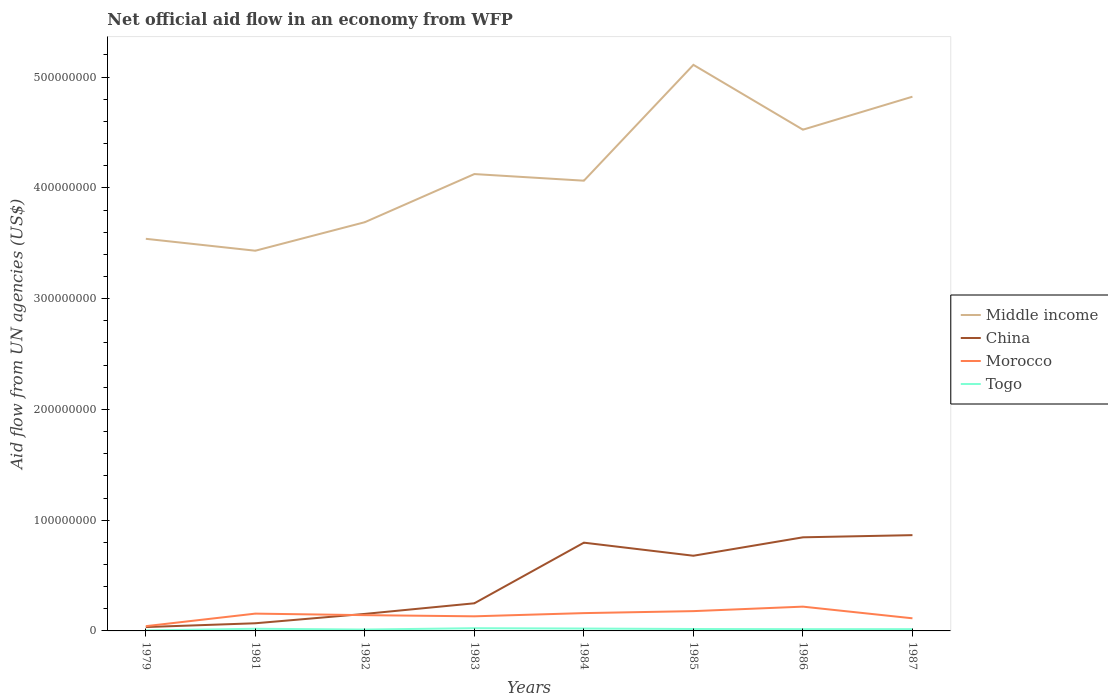How many different coloured lines are there?
Provide a succinct answer. 4. Does the line corresponding to Morocco intersect with the line corresponding to China?
Provide a short and direct response. Yes. What is the total net official aid flow in Morocco in the graph?
Your answer should be very brief. -9.95e+06. What is the difference between the highest and the second highest net official aid flow in China?
Your answer should be very brief. 8.30e+07. What is the difference between the highest and the lowest net official aid flow in Togo?
Ensure brevity in your answer.  4. Is the net official aid flow in Togo strictly greater than the net official aid flow in Middle income over the years?
Offer a very short reply. Yes. How many lines are there?
Offer a terse response. 4. How many years are there in the graph?
Keep it short and to the point. 8. Does the graph contain any zero values?
Your answer should be compact. No. Does the graph contain grids?
Ensure brevity in your answer.  No. How many legend labels are there?
Your response must be concise. 4. What is the title of the graph?
Your answer should be compact. Net official aid flow in an economy from WFP. What is the label or title of the Y-axis?
Ensure brevity in your answer.  Aid flow from UN agencies (US$). What is the Aid flow from UN agencies (US$) in Middle income in 1979?
Provide a short and direct response. 3.54e+08. What is the Aid flow from UN agencies (US$) of China in 1979?
Offer a very short reply. 3.48e+06. What is the Aid flow from UN agencies (US$) in Morocco in 1979?
Your answer should be very brief. 4.29e+06. What is the Aid flow from UN agencies (US$) in Middle income in 1981?
Keep it short and to the point. 3.43e+08. What is the Aid flow from UN agencies (US$) of China in 1981?
Provide a short and direct response. 6.91e+06. What is the Aid flow from UN agencies (US$) of Morocco in 1981?
Keep it short and to the point. 1.56e+07. What is the Aid flow from UN agencies (US$) in Togo in 1981?
Provide a succinct answer. 1.96e+06. What is the Aid flow from UN agencies (US$) in Middle income in 1982?
Provide a succinct answer. 3.69e+08. What is the Aid flow from UN agencies (US$) of China in 1982?
Make the answer very short. 1.54e+07. What is the Aid flow from UN agencies (US$) in Morocco in 1982?
Provide a succinct answer. 1.42e+07. What is the Aid flow from UN agencies (US$) of Togo in 1982?
Offer a terse response. 1.24e+06. What is the Aid flow from UN agencies (US$) of Middle income in 1983?
Your response must be concise. 4.12e+08. What is the Aid flow from UN agencies (US$) of China in 1983?
Keep it short and to the point. 2.50e+07. What is the Aid flow from UN agencies (US$) in Morocco in 1983?
Provide a short and direct response. 1.32e+07. What is the Aid flow from UN agencies (US$) of Togo in 1983?
Provide a succinct answer. 2.45e+06. What is the Aid flow from UN agencies (US$) in Middle income in 1984?
Provide a succinct answer. 4.06e+08. What is the Aid flow from UN agencies (US$) in China in 1984?
Offer a terse response. 7.97e+07. What is the Aid flow from UN agencies (US$) in Morocco in 1984?
Give a very brief answer. 1.61e+07. What is the Aid flow from UN agencies (US$) in Togo in 1984?
Your response must be concise. 2.15e+06. What is the Aid flow from UN agencies (US$) in Middle income in 1985?
Ensure brevity in your answer.  5.11e+08. What is the Aid flow from UN agencies (US$) of China in 1985?
Give a very brief answer. 6.79e+07. What is the Aid flow from UN agencies (US$) in Morocco in 1985?
Your answer should be very brief. 1.79e+07. What is the Aid flow from UN agencies (US$) of Togo in 1985?
Your response must be concise. 1.74e+06. What is the Aid flow from UN agencies (US$) of Middle income in 1986?
Keep it short and to the point. 4.53e+08. What is the Aid flow from UN agencies (US$) in China in 1986?
Keep it short and to the point. 8.45e+07. What is the Aid flow from UN agencies (US$) in Morocco in 1986?
Provide a succinct answer. 2.19e+07. What is the Aid flow from UN agencies (US$) of Togo in 1986?
Give a very brief answer. 1.58e+06. What is the Aid flow from UN agencies (US$) of Middle income in 1987?
Provide a succinct answer. 4.82e+08. What is the Aid flow from UN agencies (US$) of China in 1987?
Offer a terse response. 8.65e+07. What is the Aid flow from UN agencies (US$) of Morocco in 1987?
Provide a succinct answer. 1.14e+07. What is the Aid flow from UN agencies (US$) of Togo in 1987?
Your answer should be very brief. 1.59e+06. Across all years, what is the maximum Aid flow from UN agencies (US$) in Middle income?
Offer a very short reply. 5.11e+08. Across all years, what is the maximum Aid flow from UN agencies (US$) in China?
Provide a succinct answer. 8.65e+07. Across all years, what is the maximum Aid flow from UN agencies (US$) in Morocco?
Your answer should be very brief. 2.19e+07. Across all years, what is the maximum Aid flow from UN agencies (US$) in Togo?
Offer a very short reply. 2.45e+06. Across all years, what is the minimum Aid flow from UN agencies (US$) in Middle income?
Your answer should be compact. 3.43e+08. Across all years, what is the minimum Aid flow from UN agencies (US$) of China?
Keep it short and to the point. 3.48e+06. Across all years, what is the minimum Aid flow from UN agencies (US$) of Morocco?
Keep it short and to the point. 4.29e+06. What is the total Aid flow from UN agencies (US$) of Middle income in the graph?
Offer a terse response. 3.33e+09. What is the total Aid flow from UN agencies (US$) of China in the graph?
Your answer should be compact. 3.69e+08. What is the total Aid flow from UN agencies (US$) in Morocco in the graph?
Your answer should be very brief. 1.15e+08. What is the total Aid flow from UN agencies (US$) in Togo in the graph?
Your answer should be very brief. 1.32e+07. What is the difference between the Aid flow from UN agencies (US$) in Middle income in 1979 and that in 1981?
Offer a terse response. 1.08e+07. What is the difference between the Aid flow from UN agencies (US$) of China in 1979 and that in 1981?
Offer a terse response. -3.43e+06. What is the difference between the Aid flow from UN agencies (US$) in Morocco in 1979 and that in 1981?
Make the answer very short. -1.13e+07. What is the difference between the Aid flow from UN agencies (US$) in Togo in 1979 and that in 1981?
Keep it short and to the point. -1.49e+06. What is the difference between the Aid flow from UN agencies (US$) of Middle income in 1979 and that in 1982?
Ensure brevity in your answer.  -1.50e+07. What is the difference between the Aid flow from UN agencies (US$) in China in 1979 and that in 1982?
Make the answer very short. -1.19e+07. What is the difference between the Aid flow from UN agencies (US$) in Morocco in 1979 and that in 1982?
Give a very brief answer. -9.95e+06. What is the difference between the Aid flow from UN agencies (US$) in Togo in 1979 and that in 1982?
Make the answer very short. -7.70e+05. What is the difference between the Aid flow from UN agencies (US$) of Middle income in 1979 and that in 1983?
Offer a terse response. -5.84e+07. What is the difference between the Aid flow from UN agencies (US$) of China in 1979 and that in 1983?
Ensure brevity in your answer.  -2.15e+07. What is the difference between the Aid flow from UN agencies (US$) in Morocco in 1979 and that in 1983?
Offer a terse response. -8.90e+06. What is the difference between the Aid flow from UN agencies (US$) of Togo in 1979 and that in 1983?
Ensure brevity in your answer.  -1.98e+06. What is the difference between the Aid flow from UN agencies (US$) of Middle income in 1979 and that in 1984?
Your response must be concise. -5.25e+07. What is the difference between the Aid flow from UN agencies (US$) of China in 1979 and that in 1984?
Offer a terse response. -7.62e+07. What is the difference between the Aid flow from UN agencies (US$) in Morocco in 1979 and that in 1984?
Give a very brief answer. -1.18e+07. What is the difference between the Aid flow from UN agencies (US$) in Togo in 1979 and that in 1984?
Your answer should be compact. -1.68e+06. What is the difference between the Aid flow from UN agencies (US$) of Middle income in 1979 and that in 1985?
Keep it short and to the point. -1.57e+08. What is the difference between the Aid flow from UN agencies (US$) in China in 1979 and that in 1985?
Give a very brief answer. -6.44e+07. What is the difference between the Aid flow from UN agencies (US$) of Morocco in 1979 and that in 1985?
Keep it short and to the point. -1.36e+07. What is the difference between the Aid flow from UN agencies (US$) of Togo in 1979 and that in 1985?
Your answer should be compact. -1.27e+06. What is the difference between the Aid flow from UN agencies (US$) in Middle income in 1979 and that in 1986?
Provide a short and direct response. -9.85e+07. What is the difference between the Aid flow from UN agencies (US$) of China in 1979 and that in 1986?
Your answer should be compact. -8.10e+07. What is the difference between the Aid flow from UN agencies (US$) of Morocco in 1979 and that in 1986?
Offer a very short reply. -1.76e+07. What is the difference between the Aid flow from UN agencies (US$) in Togo in 1979 and that in 1986?
Your response must be concise. -1.11e+06. What is the difference between the Aid flow from UN agencies (US$) in Middle income in 1979 and that in 1987?
Offer a very short reply. -1.28e+08. What is the difference between the Aid flow from UN agencies (US$) of China in 1979 and that in 1987?
Offer a very short reply. -8.30e+07. What is the difference between the Aid flow from UN agencies (US$) in Morocco in 1979 and that in 1987?
Your answer should be compact. -7.10e+06. What is the difference between the Aid flow from UN agencies (US$) of Togo in 1979 and that in 1987?
Your response must be concise. -1.12e+06. What is the difference between the Aid flow from UN agencies (US$) in Middle income in 1981 and that in 1982?
Provide a short and direct response. -2.58e+07. What is the difference between the Aid flow from UN agencies (US$) in China in 1981 and that in 1982?
Your response must be concise. -8.46e+06. What is the difference between the Aid flow from UN agencies (US$) in Morocco in 1981 and that in 1982?
Give a very brief answer. 1.38e+06. What is the difference between the Aid flow from UN agencies (US$) in Togo in 1981 and that in 1982?
Your answer should be compact. 7.20e+05. What is the difference between the Aid flow from UN agencies (US$) of Middle income in 1981 and that in 1983?
Your answer should be very brief. -6.92e+07. What is the difference between the Aid flow from UN agencies (US$) of China in 1981 and that in 1983?
Your response must be concise. -1.80e+07. What is the difference between the Aid flow from UN agencies (US$) in Morocco in 1981 and that in 1983?
Make the answer very short. 2.43e+06. What is the difference between the Aid flow from UN agencies (US$) of Togo in 1981 and that in 1983?
Provide a succinct answer. -4.90e+05. What is the difference between the Aid flow from UN agencies (US$) of Middle income in 1981 and that in 1984?
Give a very brief answer. -6.32e+07. What is the difference between the Aid flow from UN agencies (US$) of China in 1981 and that in 1984?
Make the answer very short. -7.28e+07. What is the difference between the Aid flow from UN agencies (US$) in Morocco in 1981 and that in 1984?
Keep it short and to the point. -4.60e+05. What is the difference between the Aid flow from UN agencies (US$) in Middle income in 1981 and that in 1985?
Your answer should be very brief. -1.68e+08. What is the difference between the Aid flow from UN agencies (US$) of China in 1981 and that in 1985?
Keep it short and to the point. -6.10e+07. What is the difference between the Aid flow from UN agencies (US$) in Morocco in 1981 and that in 1985?
Your answer should be compact. -2.25e+06. What is the difference between the Aid flow from UN agencies (US$) of Togo in 1981 and that in 1985?
Your response must be concise. 2.20e+05. What is the difference between the Aid flow from UN agencies (US$) of Middle income in 1981 and that in 1986?
Your response must be concise. -1.09e+08. What is the difference between the Aid flow from UN agencies (US$) of China in 1981 and that in 1986?
Make the answer very short. -7.76e+07. What is the difference between the Aid flow from UN agencies (US$) in Morocco in 1981 and that in 1986?
Provide a succinct answer. -6.30e+06. What is the difference between the Aid flow from UN agencies (US$) of Middle income in 1981 and that in 1987?
Your answer should be compact. -1.39e+08. What is the difference between the Aid flow from UN agencies (US$) in China in 1981 and that in 1987?
Ensure brevity in your answer.  -7.96e+07. What is the difference between the Aid flow from UN agencies (US$) of Morocco in 1981 and that in 1987?
Ensure brevity in your answer.  4.23e+06. What is the difference between the Aid flow from UN agencies (US$) in Middle income in 1982 and that in 1983?
Provide a short and direct response. -4.34e+07. What is the difference between the Aid flow from UN agencies (US$) in China in 1982 and that in 1983?
Ensure brevity in your answer.  -9.58e+06. What is the difference between the Aid flow from UN agencies (US$) of Morocco in 1982 and that in 1983?
Make the answer very short. 1.05e+06. What is the difference between the Aid flow from UN agencies (US$) of Togo in 1982 and that in 1983?
Your answer should be very brief. -1.21e+06. What is the difference between the Aid flow from UN agencies (US$) of Middle income in 1982 and that in 1984?
Provide a short and direct response. -3.75e+07. What is the difference between the Aid flow from UN agencies (US$) of China in 1982 and that in 1984?
Your response must be concise. -6.43e+07. What is the difference between the Aid flow from UN agencies (US$) in Morocco in 1982 and that in 1984?
Give a very brief answer. -1.84e+06. What is the difference between the Aid flow from UN agencies (US$) of Togo in 1982 and that in 1984?
Give a very brief answer. -9.10e+05. What is the difference between the Aid flow from UN agencies (US$) in Middle income in 1982 and that in 1985?
Make the answer very short. -1.42e+08. What is the difference between the Aid flow from UN agencies (US$) in China in 1982 and that in 1985?
Your answer should be very brief. -5.25e+07. What is the difference between the Aid flow from UN agencies (US$) of Morocco in 1982 and that in 1985?
Give a very brief answer. -3.63e+06. What is the difference between the Aid flow from UN agencies (US$) of Togo in 1982 and that in 1985?
Provide a short and direct response. -5.00e+05. What is the difference between the Aid flow from UN agencies (US$) of Middle income in 1982 and that in 1986?
Make the answer very short. -8.35e+07. What is the difference between the Aid flow from UN agencies (US$) in China in 1982 and that in 1986?
Provide a succinct answer. -6.91e+07. What is the difference between the Aid flow from UN agencies (US$) in Morocco in 1982 and that in 1986?
Make the answer very short. -7.68e+06. What is the difference between the Aid flow from UN agencies (US$) in Middle income in 1982 and that in 1987?
Offer a terse response. -1.13e+08. What is the difference between the Aid flow from UN agencies (US$) in China in 1982 and that in 1987?
Make the answer very short. -7.11e+07. What is the difference between the Aid flow from UN agencies (US$) of Morocco in 1982 and that in 1987?
Your answer should be compact. 2.85e+06. What is the difference between the Aid flow from UN agencies (US$) in Togo in 1982 and that in 1987?
Ensure brevity in your answer.  -3.50e+05. What is the difference between the Aid flow from UN agencies (US$) in Middle income in 1983 and that in 1984?
Provide a succinct answer. 5.98e+06. What is the difference between the Aid flow from UN agencies (US$) of China in 1983 and that in 1984?
Provide a succinct answer. -5.47e+07. What is the difference between the Aid flow from UN agencies (US$) in Morocco in 1983 and that in 1984?
Provide a succinct answer. -2.89e+06. What is the difference between the Aid flow from UN agencies (US$) in Middle income in 1983 and that in 1985?
Offer a very short reply. -9.86e+07. What is the difference between the Aid flow from UN agencies (US$) of China in 1983 and that in 1985?
Keep it short and to the point. -4.29e+07. What is the difference between the Aid flow from UN agencies (US$) of Morocco in 1983 and that in 1985?
Ensure brevity in your answer.  -4.68e+06. What is the difference between the Aid flow from UN agencies (US$) of Togo in 1983 and that in 1985?
Offer a very short reply. 7.10e+05. What is the difference between the Aid flow from UN agencies (US$) in Middle income in 1983 and that in 1986?
Your response must be concise. -4.01e+07. What is the difference between the Aid flow from UN agencies (US$) of China in 1983 and that in 1986?
Ensure brevity in your answer.  -5.96e+07. What is the difference between the Aid flow from UN agencies (US$) of Morocco in 1983 and that in 1986?
Make the answer very short. -8.73e+06. What is the difference between the Aid flow from UN agencies (US$) in Togo in 1983 and that in 1986?
Keep it short and to the point. 8.70e+05. What is the difference between the Aid flow from UN agencies (US$) of Middle income in 1983 and that in 1987?
Offer a terse response. -6.99e+07. What is the difference between the Aid flow from UN agencies (US$) of China in 1983 and that in 1987?
Your response must be concise. -6.15e+07. What is the difference between the Aid flow from UN agencies (US$) in Morocco in 1983 and that in 1987?
Your response must be concise. 1.80e+06. What is the difference between the Aid flow from UN agencies (US$) in Togo in 1983 and that in 1987?
Offer a very short reply. 8.60e+05. What is the difference between the Aid flow from UN agencies (US$) in Middle income in 1984 and that in 1985?
Your answer should be compact. -1.05e+08. What is the difference between the Aid flow from UN agencies (US$) in China in 1984 and that in 1985?
Give a very brief answer. 1.18e+07. What is the difference between the Aid flow from UN agencies (US$) of Morocco in 1984 and that in 1985?
Your response must be concise. -1.79e+06. What is the difference between the Aid flow from UN agencies (US$) in Togo in 1984 and that in 1985?
Make the answer very short. 4.10e+05. What is the difference between the Aid flow from UN agencies (US$) in Middle income in 1984 and that in 1986?
Keep it short and to the point. -4.60e+07. What is the difference between the Aid flow from UN agencies (US$) of China in 1984 and that in 1986?
Make the answer very short. -4.83e+06. What is the difference between the Aid flow from UN agencies (US$) in Morocco in 1984 and that in 1986?
Offer a terse response. -5.84e+06. What is the difference between the Aid flow from UN agencies (US$) of Togo in 1984 and that in 1986?
Provide a short and direct response. 5.70e+05. What is the difference between the Aid flow from UN agencies (US$) in Middle income in 1984 and that in 1987?
Keep it short and to the point. -7.58e+07. What is the difference between the Aid flow from UN agencies (US$) of China in 1984 and that in 1987?
Your response must be concise. -6.79e+06. What is the difference between the Aid flow from UN agencies (US$) in Morocco in 1984 and that in 1987?
Your answer should be very brief. 4.69e+06. What is the difference between the Aid flow from UN agencies (US$) in Togo in 1984 and that in 1987?
Your answer should be very brief. 5.60e+05. What is the difference between the Aid flow from UN agencies (US$) of Middle income in 1985 and that in 1986?
Ensure brevity in your answer.  5.85e+07. What is the difference between the Aid flow from UN agencies (US$) in China in 1985 and that in 1986?
Your answer should be compact. -1.66e+07. What is the difference between the Aid flow from UN agencies (US$) in Morocco in 1985 and that in 1986?
Your answer should be very brief. -4.05e+06. What is the difference between the Aid flow from UN agencies (US$) in Togo in 1985 and that in 1986?
Your answer should be compact. 1.60e+05. What is the difference between the Aid flow from UN agencies (US$) of Middle income in 1985 and that in 1987?
Keep it short and to the point. 2.87e+07. What is the difference between the Aid flow from UN agencies (US$) of China in 1985 and that in 1987?
Ensure brevity in your answer.  -1.86e+07. What is the difference between the Aid flow from UN agencies (US$) of Morocco in 1985 and that in 1987?
Ensure brevity in your answer.  6.48e+06. What is the difference between the Aid flow from UN agencies (US$) of Middle income in 1986 and that in 1987?
Provide a succinct answer. -2.98e+07. What is the difference between the Aid flow from UN agencies (US$) in China in 1986 and that in 1987?
Keep it short and to the point. -1.96e+06. What is the difference between the Aid flow from UN agencies (US$) of Morocco in 1986 and that in 1987?
Ensure brevity in your answer.  1.05e+07. What is the difference between the Aid flow from UN agencies (US$) in Togo in 1986 and that in 1987?
Keep it short and to the point. -10000. What is the difference between the Aid flow from UN agencies (US$) of Middle income in 1979 and the Aid flow from UN agencies (US$) of China in 1981?
Keep it short and to the point. 3.47e+08. What is the difference between the Aid flow from UN agencies (US$) of Middle income in 1979 and the Aid flow from UN agencies (US$) of Morocco in 1981?
Offer a terse response. 3.38e+08. What is the difference between the Aid flow from UN agencies (US$) in Middle income in 1979 and the Aid flow from UN agencies (US$) in Togo in 1981?
Give a very brief answer. 3.52e+08. What is the difference between the Aid flow from UN agencies (US$) in China in 1979 and the Aid flow from UN agencies (US$) in Morocco in 1981?
Your answer should be compact. -1.21e+07. What is the difference between the Aid flow from UN agencies (US$) in China in 1979 and the Aid flow from UN agencies (US$) in Togo in 1981?
Provide a short and direct response. 1.52e+06. What is the difference between the Aid flow from UN agencies (US$) in Morocco in 1979 and the Aid flow from UN agencies (US$) in Togo in 1981?
Keep it short and to the point. 2.33e+06. What is the difference between the Aid flow from UN agencies (US$) in Middle income in 1979 and the Aid flow from UN agencies (US$) in China in 1982?
Your response must be concise. 3.39e+08. What is the difference between the Aid flow from UN agencies (US$) in Middle income in 1979 and the Aid flow from UN agencies (US$) in Morocco in 1982?
Provide a succinct answer. 3.40e+08. What is the difference between the Aid flow from UN agencies (US$) of Middle income in 1979 and the Aid flow from UN agencies (US$) of Togo in 1982?
Your answer should be very brief. 3.53e+08. What is the difference between the Aid flow from UN agencies (US$) of China in 1979 and the Aid flow from UN agencies (US$) of Morocco in 1982?
Keep it short and to the point. -1.08e+07. What is the difference between the Aid flow from UN agencies (US$) of China in 1979 and the Aid flow from UN agencies (US$) of Togo in 1982?
Offer a very short reply. 2.24e+06. What is the difference between the Aid flow from UN agencies (US$) in Morocco in 1979 and the Aid flow from UN agencies (US$) in Togo in 1982?
Offer a very short reply. 3.05e+06. What is the difference between the Aid flow from UN agencies (US$) of Middle income in 1979 and the Aid flow from UN agencies (US$) of China in 1983?
Ensure brevity in your answer.  3.29e+08. What is the difference between the Aid flow from UN agencies (US$) in Middle income in 1979 and the Aid flow from UN agencies (US$) in Morocco in 1983?
Provide a succinct answer. 3.41e+08. What is the difference between the Aid flow from UN agencies (US$) in Middle income in 1979 and the Aid flow from UN agencies (US$) in Togo in 1983?
Offer a very short reply. 3.52e+08. What is the difference between the Aid flow from UN agencies (US$) in China in 1979 and the Aid flow from UN agencies (US$) in Morocco in 1983?
Keep it short and to the point. -9.71e+06. What is the difference between the Aid flow from UN agencies (US$) in China in 1979 and the Aid flow from UN agencies (US$) in Togo in 1983?
Your response must be concise. 1.03e+06. What is the difference between the Aid flow from UN agencies (US$) in Morocco in 1979 and the Aid flow from UN agencies (US$) in Togo in 1983?
Your answer should be very brief. 1.84e+06. What is the difference between the Aid flow from UN agencies (US$) in Middle income in 1979 and the Aid flow from UN agencies (US$) in China in 1984?
Your answer should be very brief. 2.74e+08. What is the difference between the Aid flow from UN agencies (US$) in Middle income in 1979 and the Aid flow from UN agencies (US$) in Morocco in 1984?
Give a very brief answer. 3.38e+08. What is the difference between the Aid flow from UN agencies (US$) of Middle income in 1979 and the Aid flow from UN agencies (US$) of Togo in 1984?
Give a very brief answer. 3.52e+08. What is the difference between the Aid flow from UN agencies (US$) in China in 1979 and the Aid flow from UN agencies (US$) in Morocco in 1984?
Keep it short and to the point. -1.26e+07. What is the difference between the Aid flow from UN agencies (US$) of China in 1979 and the Aid flow from UN agencies (US$) of Togo in 1984?
Your response must be concise. 1.33e+06. What is the difference between the Aid flow from UN agencies (US$) of Morocco in 1979 and the Aid flow from UN agencies (US$) of Togo in 1984?
Your answer should be very brief. 2.14e+06. What is the difference between the Aid flow from UN agencies (US$) in Middle income in 1979 and the Aid flow from UN agencies (US$) in China in 1985?
Ensure brevity in your answer.  2.86e+08. What is the difference between the Aid flow from UN agencies (US$) in Middle income in 1979 and the Aid flow from UN agencies (US$) in Morocco in 1985?
Provide a short and direct response. 3.36e+08. What is the difference between the Aid flow from UN agencies (US$) in Middle income in 1979 and the Aid flow from UN agencies (US$) in Togo in 1985?
Your answer should be very brief. 3.52e+08. What is the difference between the Aid flow from UN agencies (US$) in China in 1979 and the Aid flow from UN agencies (US$) in Morocco in 1985?
Make the answer very short. -1.44e+07. What is the difference between the Aid flow from UN agencies (US$) of China in 1979 and the Aid flow from UN agencies (US$) of Togo in 1985?
Your response must be concise. 1.74e+06. What is the difference between the Aid flow from UN agencies (US$) in Morocco in 1979 and the Aid flow from UN agencies (US$) in Togo in 1985?
Offer a terse response. 2.55e+06. What is the difference between the Aid flow from UN agencies (US$) of Middle income in 1979 and the Aid flow from UN agencies (US$) of China in 1986?
Make the answer very short. 2.70e+08. What is the difference between the Aid flow from UN agencies (US$) in Middle income in 1979 and the Aid flow from UN agencies (US$) in Morocco in 1986?
Provide a succinct answer. 3.32e+08. What is the difference between the Aid flow from UN agencies (US$) of Middle income in 1979 and the Aid flow from UN agencies (US$) of Togo in 1986?
Offer a very short reply. 3.52e+08. What is the difference between the Aid flow from UN agencies (US$) in China in 1979 and the Aid flow from UN agencies (US$) in Morocco in 1986?
Your answer should be compact. -1.84e+07. What is the difference between the Aid flow from UN agencies (US$) of China in 1979 and the Aid flow from UN agencies (US$) of Togo in 1986?
Provide a short and direct response. 1.90e+06. What is the difference between the Aid flow from UN agencies (US$) in Morocco in 1979 and the Aid flow from UN agencies (US$) in Togo in 1986?
Provide a succinct answer. 2.71e+06. What is the difference between the Aid flow from UN agencies (US$) of Middle income in 1979 and the Aid flow from UN agencies (US$) of China in 1987?
Make the answer very short. 2.68e+08. What is the difference between the Aid flow from UN agencies (US$) of Middle income in 1979 and the Aid flow from UN agencies (US$) of Morocco in 1987?
Provide a succinct answer. 3.43e+08. What is the difference between the Aid flow from UN agencies (US$) in Middle income in 1979 and the Aid flow from UN agencies (US$) in Togo in 1987?
Ensure brevity in your answer.  3.52e+08. What is the difference between the Aid flow from UN agencies (US$) of China in 1979 and the Aid flow from UN agencies (US$) of Morocco in 1987?
Offer a very short reply. -7.91e+06. What is the difference between the Aid flow from UN agencies (US$) of China in 1979 and the Aid flow from UN agencies (US$) of Togo in 1987?
Provide a short and direct response. 1.89e+06. What is the difference between the Aid flow from UN agencies (US$) of Morocco in 1979 and the Aid flow from UN agencies (US$) of Togo in 1987?
Give a very brief answer. 2.70e+06. What is the difference between the Aid flow from UN agencies (US$) of Middle income in 1981 and the Aid flow from UN agencies (US$) of China in 1982?
Offer a terse response. 3.28e+08. What is the difference between the Aid flow from UN agencies (US$) in Middle income in 1981 and the Aid flow from UN agencies (US$) in Morocco in 1982?
Keep it short and to the point. 3.29e+08. What is the difference between the Aid flow from UN agencies (US$) in Middle income in 1981 and the Aid flow from UN agencies (US$) in Togo in 1982?
Make the answer very short. 3.42e+08. What is the difference between the Aid flow from UN agencies (US$) of China in 1981 and the Aid flow from UN agencies (US$) of Morocco in 1982?
Keep it short and to the point. -7.33e+06. What is the difference between the Aid flow from UN agencies (US$) of China in 1981 and the Aid flow from UN agencies (US$) of Togo in 1982?
Your answer should be very brief. 5.67e+06. What is the difference between the Aid flow from UN agencies (US$) of Morocco in 1981 and the Aid flow from UN agencies (US$) of Togo in 1982?
Provide a short and direct response. 1.44e+07. What is the difference between the Aid flow from UN agencies (US$) of Middle income in 1981 and the Aid flow from UN agencies (US$) of China in 1983?
Give a very brief answer. 3.18e+08. What is the difference between the Aid flow from UN agencies (US$) of Middle income in 1981 and the Aid flow from UN agencies (US$) of Morocco in 1983?
Your answer should be very brief. 3.30e+08. What is the difference between the Aid flow from UN agencies (US$) in Middle income in 1981 and the Aid flow from UN agencies (US$) in Togo in 1983?
Offer a very short reply. 3.41e+08. What is the difference between the Aid flow from UN agencies (US$) of China in 1981 and the Aid flow from UN agencies (US$) of Morocco in 1983?
Ensure brevity in your answer.  -6.28e+06. What is the difference between the Aid flow from UN agencies (US$) in China in 1981 and the Aid flow from UN agencies (US$) in Togo in 1983?
Your answer should be very brief. 4.46e+06. What is the difference between the Aid flow from UN agencies (US$) of Morocco in 1981 and the Aid flow from UN agencies (US$) of Togo in 1983?
Give a very brief answer. 1.32e+07. What is the difference between the Aid flow from UN agencies (US$) in Middle income in 1981 and the Aid flow from UN agencies (US$) in China in 1984?
Provide a short and direct response. 2.64e+08. What is the difference between the Aid flow from UN agencies (US$) in Middle income in 1981 and the Aid flow from UN agencies (US$) in Morocco in 1984?
Make the answer very short. 3.27e+08. What is the difference between the Aid flow from UN agencies (US$) in Middle income in 1981 and the Aid flow from UN agencies (US$) in Togo in 1984?
Ensure brevity in your answer.  3.41e+08. What is the difference between the Aid flow from UN agencies (US$) in China in 1981 and the Aid flow from UN agencies (US$) in Morocco in 1984?
Ensure brevity in your answer.  -9.17e+06. What is the difference between the Aid flow from UN agencies (US$) in China in 1981 and the Aid flow from UN agencies (US$) in Togo in 1984?
Keep it short and to the point. 4.76e+06. What is the difference between the Aid flow from UN agencies (US$) of Morocco in 1981 and the Aid flow from UN agencies (US$) of Togo in 1984?
Offer a terse response. 1.35e+07. What is the difference between the Aid flow from UN agencies (US$) in Middle income in 1981 and the Aid flow from UN agencies (US$) in China in 1985?
Your response must be concise. 2.75e+08. What is the difference between the Aid flow from UN agencies (US$) of Middle income in 1981 and the Aid flow from UN agencies (US$) of Morocco in 1985?
Keep it short and to the point. 3.25e+08. What is the difference between the Aid flow from UN agencies (US$) in Middle income in 1981 and the Aid flow from UN agencies (US$) in Togo in 1985?
Provide a succinct answer. 3.42e+08. What is the difference between the Aid flow from UN agencies (US$) in China in 1981 and the Aid flow from UN agencies (US$) in Morocco in 1985?
Your response must be concise. -1.10e+07. What is the difference between the Aid flow from UN agencies (US$) of China in 1981 and the Aid flow from UN agencies (US$) of Togo in 1985?
Offer a very short reply. 5.17e+06. What is the difference between the Aid flow from UN agencies (US$) in Morocco in 1981 and the Aid flow from UN agencies (US$) in Togo in 1985?
Ensure brevity in your answer.  1.39e+07. What is the difference between the Aid flow from UN agencies (US$) of Middle income in 1981 and the Aid flow from UN agencies (US$) of China in 1986?
Your response must be concise. 2.59e+08. What is the difference between the Aid flow from UN agencies (US$) of Middle income in 1981 and the Aid flow from UN agencies (US$) of Morocco in 1986?
Provide a succinct answer. 3.21e+08. What is the difference between the Aid flow from UN agencies (US$) of Middle income in 1981 and the Aid flow from UN agencies (US$) of Togo in 1986?
Offer a very short reply. 3.42e+08. What is the difference between the Aid flow from UN agencies (US$) of China in 1981 and the Aid flow from UN agencies (US$) of Morocco in 1986?
Provide a succinct answer. -1.50e+07. What is the difference between the Aid flow from UN agencies (US$) of China in 1981 and the Aid flow from UN agencies (US$) of Togo in 1986?
Your answer should be compact. 5.33e+06. What is the difference between the Aid flow from UN agencies (US$) in Morocco in 1981 and the Aid flow from UN agencies (US$) in Togo in 1986?
Offer a very short reply. 1.40e+07. What is the difference between the Aid flow from UN agencies (US$) in Middle income in 1981 and the Aid flow from UN agencies (US$) in China in 1987?
Your response must be concise. 2.57e+08. What is the difference between the Aid flow from UN agencies (US$) in Middle income in 1981 and the Aid flow from UN agencies (US$) in Morocco in 1987?
Your response must be concise. 3.32e+08. What is the difference between the Aid flow from UN agencies (US$) in Middle income in 1981 and the Aid flow from UN agencies (US$) in Togo in 1987?
Give a very brief answer. 3.42e+08. What is the difference between the Aid flow from UN agencies (US$) in China in 1981 and the Aid flow from UN agencies (US$) in Morocco in 1987?
Ensure brevity in your answer.  -4.48e+06. What is the difference between the Aid flow from UN agencies (US$) of China in 1981 and the Aid flow from UN agencies (US$) of Togo in 1987?
Keep it short and to the point. 5.32e+06. What is the difference between the Aid flow from UN agencies (US$) in Morocco in 1981 and the Aid flow from UN agencies (US$) in Togo in 1987?
Give a very brief answer. 1.40e+07. What is the difference between the Aid flow from UN agencies (US$) of Middle income in 1982 and the Aid flow from UN agencies (US$) of China in 1983?
Your response must be concise. 3.44e+08. What is the difference between the Aid flow from UN agencies (US$) of Middle income in 1982 and the Aid flow from UN agencies (US$) of Morocco in 1983?
Your answer should be compact. 3.56e+08. What is the difference between the Aid flow from UN agencies (US$) in Middle income in 1982 and the Aid flow from UN agencies (US$) in Togo in 1983?
Keep it short and to the point. 3.67e+08. What is the difference between the Aid flow from UN agencies (US$) of China in 1982 and the Aid flow from UN agencies (US$) of Morocco in 1983?
Your answer should be very brief. 2.18e+06. What is the difference between the Aid flow from UN agencies (US$) of China in 1982 and the Aid flow from UN agencies (US$) of Togo in 1983?
Your response must be concise. 1.29e+07. What is the difference between the Aid flow from UN agencies (US$) in Morocco in 1982 and the Aid flow from UN agencies (US$) in Togo in 1983?
Give a very brief answer. 1.18e+07. What is the difference between the Aid flow from UN agencies (US$) in Middle income in 1982 and the Aid flow from UN agencies (US$) in China in 1984?
Your response must be concise. 2.89e+08. What is the difference between the Aid flow from UN agencies (US$) in Middle income in 1982 and the Aid flow from UN agencies (US$) in Morocco in 1984?
Keep it short and to the point. 3.53e+08. What is the difference between the Aid flow from UN agencies (US$) of Middle income in 1982 and the Aid flow from UN agencies (US$) of Togo in 1984?
Your response must be concise. 3.67e+08. What is the difference between the Aid flow from UN agencies (US$) of China in 1982 and the Aid flow from UN agencies (US$) of Morocco in 1984?
Your response must be concise. -7.10e+05. What is the difference between the Aid flow from UN agencies (US$) in China in 1982 and the Aid flow from UN agencies (US$) in Togo in 1984?
Provide a short and direct response. 1.32e+07. What is the difference between the Aid flow from UN agencies (US$) of Morocco in 1982 and the Aid flow from UN agencies (US$) of Togo in 1984?
Provide a short and direct response. 1.21e+07. What is the difference between the Aid flow from UN agencies (US$) of Middle income in 1982 and the Aid flow from UN agencies (US$) of China in 1985?
Ensure brevity in your answer.  3.01e+08. What is the difference between the Aid flow from UN agencies (US$) of Middle income in 1982 and the Aid flow from UN agencies (US$) of Morocco in 1985?
Offer a very short reply. 3.51e+08. What is the difference between the Aid flow from UN agencies (US$) of Middle income in 1982 and the Aid flow from UN agencies (US$) of Togo in 1985?
Offer a terse response. 3.67e+08. What is the difference between the Aid flow from UN agencies (US$) in China in 1982 and the Aid flow from UN agencies (US$) in Morocco in 1985?
Your answer should be very brief. -2.50e+06. What is the difference between the Aid flow from UN agencies (US$) of China in 1982 and the Aid flow from UN agencies (US$) of Togo in 1985?
Ensure brevity in your answer.  1.36e+07. What is the difference between the Aid flow from UN agencies (US$) in Morocco in 1982 and the Aid flow from UN agencies (US$) in Togo in 1985?
Offer a very short reply. 1.25e+07. What is the difference between the Aid flow from UN agencies (US$) of Middle income in 1982 and the Aid flow from UN agencies (US$) of China in 1986?
Give a very brief answer. 2.85e+08. What is the difference between the Aid flow from UN agencies (US$) of Middle income in 1982 and the Aid flow from UN agencies (US$) of Morocco in 1986?
Make the answer very short. 3.47e+08. What is the difference between the Aid flow from UN agencies (US$) of Middle income in 1982 and the Aid flow from UN agencies (US$) of Togo in 1986?
Your response must be concise. 3.67e+08. What is the difference between the Aid flow from UN agencies (US$) of China in 1982 and the Aid flow from UN agencies (US$) of Morocco in 1986?
Offer a terse response. -6.55e+06. What is the difference between the Aid flow from UN agencies (US$) in China in 1982 and the Aid flow from UN agencies (US$) in Togo in 1986?
Keep it short and to the point. 1.38e+07. What is the difference between the Aid flow from UN agencies (US$) of Morocco in 1982 and the Aid flow from UN agencies (US$) of Togo in 1986?
Ensure brevity in your answer.  1.27e+07. What is the difference between the Aid flow from UN agencies (US$) of Middle income in 1982 and the Aid flow from UN agencies (US$) of China in 1987?
Ensure brevity in your answer.  2.83e+08. What is the difference between the Aid flow from UN agencies (US$) of Middle income in 1982 and the Aid flow from UN agencies (US$) of Morocco in 1987?
Make the answer very short. 3.58e+08. What is the difference between the Aid flow from UN agencies (US$) in Middle income in 1982 and the Aid flow from UN agencies (US$) in Togo in 1987?
Make the answer very short. 3.67e+08. What is the difference between the Aid flow from UN agencies (US$) in China in 1982 and the Aid flow from UN agencies (US$) in Morocco in 1987?
Ensure brevity in your answer.  3.98e+06. What is the difference between the Aid flow from UN agencies (US$) of China in 1982 and the Aid flow from UN agencies (US$) of Togo in 1987?
Your answer should be compact. 1.38e+07. What is the difference between the Aid flow from UN agencies (US$) of Morocco in 1982 and the Aid flow from UN agencies (US$) of Togo in 1987?
Offer a very short reply. 1.26e+07. What is the difference between the Aid flow from UN agencies (US$) of Middle income in 1983 and the Aid flow from UN agencies (US$) of China in 1984?
Your answer should be very brief. 3.33e+08. What is the difference between the Aid flow from UN agencies (US$) in Middle income in 1983 and the Aid flow from UN agencies (US$) in Morocco in 1984?
Make the answer very short. 3.96e+08. What is the difference between the Aid flow from UN agencies (US$) in Middle income in 1983 and the Aid flow from UN agencies (US$) in Togo in 1984?
Your answer should be very brief. 4.10e+08. What is the difference between the Aid flow from UN agencies (US$) of China in 1983 and the Aid flow from UN agencies (US$) of Morocco in 1984?
Offer a terse response. 8.87e+06. What is the difference between the Aid flow from UN agencies (US$) of China in 1983 and the Aid flow from UN agencies (US$) of Togo in 1984?
Your answer should be compact. 2.28e+07. What is the difference between the Aid flow from UN agencies (US$) of Morocco in 1983 and the Aid flow from UN agencies (US$) of Togo in 1984?
Give a very brief answer. 1.10e+07. What is the difference between the Aid flow from UN agencies (US$) of Middle income in 1983 and the Aid flow from UN agencies (US$) of China in 1985?
Your answer should be very brief. 3.45e+08. What is the difference between the Aid flow from UN agencies (US$) of Middle income in 1983 and the Aid flow from UN agencies (US$) of Morocco in 1985?
Provide a short and direct response. 3.95e+08. What is the difference between the Aid flow from UN agencies (US$) of Middle income in 1983 and the Aid flow from UN agencies (US$) of Togo in 1985?
Make the answer very short. 4.11e+08. What is the difference between the Aid flow from UN agencies (US$) of China in 1983 and the Aid flow from UN agencies (US$) of Morocco in 1985?
Offer a very short reply. 7.08e+06. What is the difference between the Aid flow from UN agencies (US$) in China in 1983 and the Aid flow from UN agencies (US$) in Togo in 1985?
Your answer should be very brief. 2.32e+07. What is the difference between the Aid flow from UN agencies (US$) of Morocco in 1983 and the Aid flow from UN agencies (US$) of Togo in 1985?
Offer a very short reply. 1.14e+07. What is the difference between the Aid flow from UN agencies (US$) of Middle income in 1983 and the Aid flow from UN agencies (US$) of China in 1986?
Provide a short and direct response. 3.28e+08. What is the difference between the Aid flow from UN agencies (US$) in Middle income in 1983 and the Aid flow from UN agencies (US$) in Morocco in 1986?
Your answer should be very brief. 3.91e+08. What is the difference between the Aid flow from UN agencies (US$) in Middle income in 1983 and the Aid flow from UN agencies (US$) in Togo in 1986?
Your response must be concise. 4.11e+08. What is the difference between the Aid flow from UN agencies (US$) in China in 1983 and the Aid flow from UN agencies (US$) in Morocco in 1986?
Offer a terse response. 3.03e+06. What is the difference between the Aid flow from UN agencies (US$) in China in 1983 and the Aid flow from UN agencies (US$) in Togo in 1986?
Provide a succinct answer. 2.34e+07. What is the difference between the Aid flow from UN agencies (US$) of Morocco in 1983 and the Aid flow from UN agencies (US$) of Togo in 1986?
Make the answer very short. 1.16e+07. What is the difference between the Aid flow from UN agencies (US$) in Middle income in 1983 and the Aid flow from UN agencies (US$) in China in 1987?
Offer a very short reply. 3.26e+08. What is the difference between the Aid flow from UN agencies (US$) in Middle income in 1983 and the Aid flow from UN agencies (US$) in Morocco in 1987?
Provide a succinct answer. 4.01e+08. What is the difference between the Aid flow from UN agencies (US$) in Middle income in 1983 and the Aid flow from UN agencies (US$) in Togo in 1987?
Ensure brevity in your answer.  4.11e+08. What is the difference between the Aid flow from UN agencies (US$) of China in 1983 and the Aid flow from UN agencies (US$) of Morocco in 1987?
Your answer should be very brief. 1.36e+07. What is the difference between the Aid flow from UN agencies (US$) of China in 1983 and the Aid flow from UN agencies (US$) of Togo in 1987?
Make the answer very short. 2.34e+07. What is the difference between the Aid flow from UN agencies (US$) in Morocco in 1983 and the Aid flow from UN agencies (US$) in Togo in 1987?
Your answer should be compact. 1.16e+07. What is the difference between the Aid flow from UN agencies (US$) of Middle income in 1984 and the Aid flow from UN agencies (US$) of China in 1985?
Provide a short and direct response. 3.39e+08. What is the difference between the Aid flow from UN agencies (US$) of Middle income in 1984 and the Aid flow from UN agencies (US$) of Morocco in 1985?
Provide a succinct answer. 3.89e+08. What is the difference between the Aid flow from UN agencies (US$) of Middle income in 1984 and the Aid flow from UN agencies (US$) of Togo in 1985?
Your response must be concise. 4.05e+08. What is the difference between the Aid flow from UN agencies (US$) of China in 1984 and the Aid flow from UN agencies (US$) of Morocco in 1985?
Ensure brevity in your answer.  6.18e+07. What is the difference between the Aid flow from UN agencies (US$) in China in 1984 and the Aid flow from UN agencies (US$) in Togo in 1985?
Provide a short and direct response. 7.79e+07. What is the difference between the Aid flow from UN agencies (US$) of Morocco in 1984 and the Aid flow from UN agencies (US$) of Togo in 1985?
Keep it short and to the point. 1.43e+07. What is the difference between the Aid flow from UN agencies (US$) in Middle income in 1984 and the Aid flow from UN agencies (US$) in China in 1986?
Your answer should be compact. 3.22e+08. What is the difference between the Aid flow from UN agencies (US$) of Middle income in 1984 and the Aid flow from UN agencies (US$) of Morocco in 1986?
Your answer should be very brief. 3.85e+08. What is the difference between the Aid flow from UN agencies (US$) in Middle income in 1984 and the Aid flow from UN agencies (US$) in Togo in 1986?
Offer a very short reply. 4.05e+08. What is the difference between the Aid flow from UN agencies (US$) in China in 1984 and the Aid flow from UN agencies (US$) in Morocco in 1986?
Provide a succinct answer. 5.78e+07. What is the difference between the Aid flow from UN agencies (US$) of China in 1984 and the Aid flow from UN agencies (US$) of Togo in 1986?
Your answer should be very brief. 7.81e+07. What is the difference between the Aid flow from UN agencies (US$) of Morocco in 1984 and the Aid flow from UN agencies (US$) of Togo in 1986?
Make the answer very short. 1.45e+07. What is the difference between the Aid flow from UN agencies (US$) of Middle income in 1984 and the Aid flow from UN agencies (US$) of China in 1987?
Provide a short and direct response. 3.20e+08. What is the difference between the Aid flow from UN agencies (US$) in Middle income in 1984 and the Aid flow from UN agencies (US$) in Morocco in 1987?
Provide a succinct answer. 3.95e+08. What is the difference between the Aid flow from UN agencies (US$) of Middle income in 1984 and the Aid flow from UN agencies (US$) of Togo in 1987?
Provide a short and direct response. 4.05e+08. What is the difference between the Aid flow from UN agencies (US$) of China in 1984 and the Aid flow from UN agencies (US$) of Morocco in 1987?
Provide a succinct answer. 6.83e+07. What is the difference between the Aid flow from UN agencies (US$) of China in 1984 and the Aid flow from UN agencies (US$) of Togo in 1987?
Provide a succinct answer. 7.81e+07. What is the difference between the Aid flow from UN agencies (US$) of Morocco in 1984 and the Aid flow from UN agencies (US$) of Togo in 1987?
Provide a succinct answer. 1.45e+07. What is the difference between the Aid flow from UN agencies (US$) of Middle income in 1985 and the Aid flow from UN agencies (US$) of China in 1986?
Provide a succinct answer. 4.27e+08. What is the difference between the Aid flow from UN agencies (US$) in Middle income in 1985 and the Aid flow from UN agencies (US$) in Morocco in 1986?
Offer a very short reply. 4.89e+08. What is the difference between the Aid flow from UN agencies (US$) in Middle income in 1985 and the Aid flow from UN agencies (US$) in Togo in 1986?
Offer a terse response. 5.10e+08. What is the difference between the Aid flow from UN agencies (US$) of China in 1985 and the Aid flow from UN agencies (US$) of Morocco in 1986?
Your answer should be compact. 4.60e+07. What is the difference between the Aid flow from UN agencies (US$) of China in 1985 and the Aid flow from UN agencies (US$) of Togo in 1986?
Your answer should be very brief. 6.63e+07. What is the difference between the Aid flow from UN agencies (US$) in Morocco in 1985 and the Aid flow from UN agencies (US$) in Togo in 1986?
Ensure brevity in your answer.  1.63e+07. What is the difference between the Aid flow from UN agencies (US$) of Middle income in 1985 and the Aid flow from UN agencies (US$) of China in 1987?
Provide a short and direct response. 4.25e+08. What is the difference between the Aid flow from UN agencies (US$) in Middle income in 1985 and the Aid flow from UN agencies (US$) in Morocco in 1987?
Provide a short and direct response. 5.00e+08. What is the difference between the Aid flow from UN agencies (US$) of Middle income in 1985 and the Aid flow from UN agencies (US$) of Togo in 1987?
Your response must be concise. 5.09e+08. What is the difference between the Aid flow from UN agencies (US$) of China in 1985 and the Aid flow from UN agencies (US$) of Morocco in 1987?
Your response must be concise. 5.65e+07. What is the difference between the Aid flow from UN agencies (US$) in China in 1985 and the Aid flow from UN agencies (US$) in Togo in 1987?
Keep it short and to the point. 6.63e+07. What is the difference between the Aid flow from UN agencies (US$) of Morocco in 1985 and the Aid flow from UN agencies (US$) of Togo in 1987?
Your answer should be very brief. 1.63e+07. What is the difference between the Aid flow from UN agencies (US$) of Middle income in 1986 and the Aid flow from UN agencies (US$) of China in 1987?
Your response must be concise. 3.66e+08. What is the difference between the Aid flow from UN agencies (US$) in Middle income in 1986 and the Aid flow from UN agencies (US$) in Morocco in 1987?
Your response must be concise. 4.41e+08. What is the difference between the Aid flow from UN agencies (US$) of Middle income in 1986 and the Aid flow from UN agencies (US$) of Togo in 1987?
Your answer should be very brief. 4.51e+08. What is the difference between the Aid flow from UN agencies (US$) in China in 1986 and the Aid flow from UN agencies (US$) in Morocco in 1987?
Make the answer very short. 7.31e+07. What is the difference between the Aid flow from UN agencies (US$) in China in 1986 and the Aid flow from UN agencies (US$) in Togo in 1987?
Ensure brevity in your answer.  8.29e+07. What is the difference between the Aid flow from UN agencies (US$) in Morocco in 1986 and the Aid flow from UN agencies (US$) in Togo in 1987?
Make the answer very short. 2.03e+07. What is the average Aid flow from UN agencies (US$) in Middle income per year?
Give a very brief answer. 4.16e+08. What is the average Aid flow from UN agencies (US$) in China per year?
Offer a very short reply. 4.62e+07. What is the average Aid flow from UN agencies (US$) in Morocco per year?
Your answer should be compact. 1.43e+07. What is the average Aid flow from UN agencies (US$) of Togo per year?
Ensure brevity in your answer.  1.65e+06. In the year 1979, what is the difference between the Aid flow from UN agencies (US$) in Middle income and Aid flow from UN agencies (US$) in China?
Provide a short and direct response. 3.51e+08. In the year 1979, what is the difference between the Aid flow from UN agencies (US$) in Middle income and Aid flow from UN agencies (US$) in Morocco?
Make the answer very short. 3.50e+08. In the year 1979, what is the difference between the Aid flow from UN agencies (US$) of Middle income and Aid flow from UN agencies (US$) of Togo?
Provide a short and direct response. 3.54e+08. In the year 1979, what is the difference between the Aid flow from UN agencies (US$) in China and Aid flow from UN agencies (US$) in Morocco?
Make the answer very short. -8.10e+05. In the year 1979, what is the difference between the Aid flow from UN agencies (US$) of China and Aid flow from UN agencies (US$) of Togo?
Offer a terse response. 3.01e+06. In the year 1979, what is the difference between the Aid flow from UN agencies (US$) in Morocco and Aid flow from UN agencies (US$) in Togo?
Provide a succinct answer. 3.82e+06. In the year 1981, what is the difference between the Aid flow from UN agencies (US$) of Middle income and Aid flow from UN agencies (US$) of China?
Give a very brief answer. 3.36e+08. In the year 1981, what is the difference between the Aid flow from UN agencies (US$) in Middle income and Aid flow from UN agencies (US$) in Morocco?
Offer a terse response. 3.28e+08. In the year 1981, what is the difference between the Aid flow from UN agencies (US$) in Middle income and Aid flow from UN agencies (US$) in Togo?
Make the answer very short. 3.41e+08. In the year 1981, what is the difference between the Aid flow from UN agencies (US$) of China and Aid flow from UN agencies (US$) of Morocco?
Your answer should be compact. -8.71e+06. In the year 1981, what is the difference between the Aid flow from UN agencies (US$) of China and Aid flow from UN agencies (US$) of Togo?
Keep it short and to the point. 4.95e+06. In the year 1981, what is the difference between the Aid flow from UN agencies (US$) in Morocco and Aid flow from UN agencies (US$) in Togo?
Provide a succinct answer. 1.37e+07. In the year 1982, what is the difference between the Aid flow from UN agencies (US$) of Middle income and Aid flow from UN agencies (US$) of China?
Your answer should be compact. 3.54e+08. In the year 1982, what is the difference between the Aid flow from UN agencies (US$) of Middle income and Aid flow from UN agencies (US$) of Morocco?
Offer a very short reply. 3.55e+08. In the year 1982, what is the difference between the Aid flow from UN agencies (US$) of Middle income and Aid flow from UN agencies (US$) of Togo?
Your answer should be very brief. 3.68e+08. In the year 1982, what is the difference between the Aid flow from UN agencies (US$) of China and Aid flow from UN agencies (US$) of Morocco?
Ensure brevity in your answer.  1.13e+06. In the year 1982, what is the difference between the Aid flow from UN agencies (US$) in China and Aid flow from UN agencies (US$) in Togo?
Your response must be concise. 1.41e+07. In the year 1982, what is the difference between the Aid flow from UN agencies (US$) in Morocco and Aid flow from UN agencies (US$) in Togo?
Provide a short and direct response. 1.30e+07. In the year 1983, what is the difference between the Aid flow from UN agencies (US$) in Middle income and Aid flow from UN agencies (US$) in China?
Provide a short and direct response. 3.88e+08. In the year 1983, what is the difference between the Aid flow from UN agencies (US$) in Middle income and Aid flow from UN agencies (US$) in Morocco?
Your answer should be very brief. 3.99e+08. In the year 1983, what is the difference between the Aid flow from UN agencies (US$) in Middle income and Aid flow from UN agencies (US$) in Togo?
Offer a very short reply. 4.10e+08. In the year 1983, what is the difference between the Aid flow from UN agencies (US$) of China and Aid flow from UN agencies (US$) of Morocco?
Offer a terse response. 1.18e+07. In the year 1983, what is the difference between the Aid flow from UN agencies (US$) in China and Aid flow from UN agencies (US$) in Togo?
Your response must be concise. 2.25e+07. In the year 1983, what is the difference between the Aid flow from UN agencies (US$) of Morocco and Aid flow from UN agencies (US$) of Togo?
Ensure brevity in your answer.  1.07e+07. In the year 1984, what is the difference between the Aid flow from UN agencies (US$) in Middle income and Aid flow from UN agencies (US$) in China?
Provide a succinct answer. 3.27e+08. In the year 1984, what is the difference between the Aid flow from UN agencies (US$) of Middle income and Aid flow from UN agencies (US$) of Morocco?
Provide a short and direct response. 3.90e+08. In the year 1984, what is the difference between the Aid flow from UN agencies (US$) of Middle income and Aid flow from UN agencies (US$) of Togo?
Offer a terse response. 4.04e+08. In the year 1984, what is the difference between the Aid flow from UN agencies (US$) of China and Aid flow from UN agencies (US$) of Morocco?
Provide a short and direct response. 6.36e+07. In the year 1984, what is the difference between the Aid flow from UN agencies (US$) in China and Aid flow from UN agencies (US$) in Togo?
Offer a terse response. 7.75e+07. In the year 1984, what is the difference between the Aid flow from UN agencies (US$) of Morocco and Aid flow from UN agencies (US$) of Togo?
Offer a terse response. 1.39e+07. In the year 1985, what is the difference between the Aid flow from UN agencies (US$) in Middle income and Aid flow from UN agencies (US$) in China?
Your answer should be very brief. 4.43e+08. In the year 1985, what is the difference between the Aid flow from UN agencies (US$) of Middle income and Aid flow from UN agencies (US$) of Morocco?
Your response must be concise. 4.93e+08. In the year 1985, what is the difference between the Aid flow from UN agencies (US$) in Middle income and Aid flow from UN agencies (US$) in Togo?
Ensure brevity in your answer.  5.09e+08. In the year 1985, what is the difference between the Aid flow from UN agencies (US$) of China and Aid flow from UN agencies (US$) of Morocco?
Offer a very short reply. 5.00e+07. In the year 1985, what is the difference between the Aid flow from UN agencies (US$) in China and Aid flow from UN agencies (US$) in Togo?
Offer a very short reply. 6.61e+07. In the year 1985, what is the difference between the Aid flow from UN agencies (US$) in Morocco and Aid flow from UN agencies (US$) in Togo?
Your answer should be very brief. 1.61e+07. In the year 1986, what is the difference between the Aid flow from UN agencies (US$) of Middle income and Aid flow from UN agencies (US$) of China?
Make the answer very short. 3.68e+08. In the year 1986, what is the difference between the Aid flow from UN agencies (US$) in Middle income and Aid flow from UN agencies (US$) in Morocco?
Provide a succinct answer. 4.31e+08. In the year 1986, what is the difference between the Aid flow from UN agencies (US$) in Middle income and Aid flow from UN agencies (US$) in Togo?
Ensure brevity in your answer.  4.51e+08. In the year 1986, what is the difference between the Aid flow from UN agencies (US$) of China and Aid flow from UN agencies (US$) of Morocco?
Provide a short and direct response. 6.26e+07. In the year 1986, what is the difference between the Aid flow from UN agencies (US$) in China and Aid flow from UN agencies (US$) in Togo?
Provide a short and direct response. 8.29e+07. In the year 1986, what is the difference between the Aid flow from UN agencies (US$) in Morocco and Aid flow from UN agencies (US$) in Togo?
Ensure brevity in your answer.  2.03e+07. In the year 1987, what is the difference between the Aid flow from UN agencies (US$) in Middle income and Aid flow from UN agencies (US$) in China?
Your response must be concise. 3.96e+08. In the year 1987, what is the difference between the Aid flow from UN agencies (US$) of Middle income and Aid flow from UN agencies (US$) of Morocco?
Give a very brief answer. 4.71e+08. In the year 1987, what is the difference between the Aid flow from UN agencies (US$) of Middle income and Aid flow from UN agencies (US$) of Togo?
Your response must be concise. 4.81e+08. In the year 1987, what is the difference between the Aid flow from UN agencies (US$) of China and Aid flow from UN agencies (US$) of Morocco?
Provide a short and direct response. 7.51e+07. In the year 1987, what is the difference between the Aid flow from UN agencies (US$) in China and Aid flow from UN agencies (US$) in Togo?
Your response must be concise. 8.49e+07. In the year 1987, what is the difference between the Aid flow from UN agencies (US$) of Morocco and Aid flow from UN agencies (US$) of Togo?
Keep it short and to the point. 9.80e+06. What is the ratio of the Aid flow from UN agencies (US$) in Middle income in 1979 to that in 1981?
Your response must be concise. 1.03. What is the ratio of the Aid flow from UN agencies (US$) of China in 1979 to that in 1981?
Offer a terse response. 0.5. What is the ratio of the Aid flow from UN agencies (US$) of Morocco in 1979 to that in 1981?
Your response must be concise. 0.27. What is the ratio of the Aid flow from UN agencies (US$) in Togo in 1979 to that in 1981?
Offer a very short reply. 0.24. What is the ratio of the Aid flow from UN agencies (US$) in Middle income in 1979 to that in 1982?
Keep it short and to the point. 0.96. What is the ratio of the Aid flow from UN agencies (US$) in China in 1979 to that in 1982?
Ensure brevity in your answer.  0.23. What is the ratio of the Aid flow from UN agencies (US$) of Morocco in 1979 to that in 1982?
Offer a terse response. 0.3. What is the ratio of the Aid flow from UN agencies (US$) in Togo in 1979 to that in 1982?
Make the answer very short. 0.38. What is the ratio of the Aid flow from UN agencies (US$) in Middle income in 1979 to that in 1983?
Give a very brief answer. 0.86. What is the ratio of the Aid flow from UN agencies (US$) of China in 1979 to that in 1983?
Provide a short and direct response. 0.14. What is the ratio of the Aid flow from UN agencies (US$) in Morocco in 1979 to that in 1983?
Offer a terse response. 0.33. What is the ratio of the Aid flow from UN agencies (US$) in Togo in 1979 to that in 1983?
Your answer should be very brief. 0.19. What is the ratio of the Aid flow from UN agencies (US$) of Middle income in 1979 to that in 1984?
Provide a short and direct response. 0.87. What is the ratio of the Aid flow from UN agencies (US$) in China in 1979 to that in 1984?
Provide a short and direct response. 0.04. What is the ratio of the Aid flow from UN agencies (US$) of Morocco in 1979 to that in 1984?
Your answer should be very brief. 0.27. What is the ratio of the Aid flow from UN agencies (US$) of Togo in 1979 to that in 1984?
Your answer should be very brief. 0.22. What is the ratio of the Aid flow from UN agencies (US$) of Middle income in 1979 to that in 1985?
Ensure brevity in your answer.  0.69. What is the ratio of the Aid flow from UN agencies (US$) in China in 1979 to that in 1985?
Your answer should be very brief. 0.05. What is the ratio of the Aid flow from UN agencies (US$) of Morocco in 1979 to that in 1985?
Ensure brevity in your answer.  0.24. What is the ratio of the Aid flow from UN agencies (US$) of Togo in 1979 to that in 1985?
Give a very brief answer. 0.27. What is the ratio of the Aid flow from UN agencies (US$) in Middle income in 1979 to that in 1986?
Your response must be concise. 0.78. What is the ratio of the Aid flow from UN agencies (US$) in China in 1979 to that in 1986?
Provide a succinct answer. 0.04. What is the ratio of the Aid flow from UN agencies (US$) of Morocco in 1979 to that in 1986?
Your answer should be very brief. 0.2. What is the ratio of the Aid flow from UN agencies (US$) of Togo in 1979 to that in 1986?
Offer a very short reply. 0.3. What is the ratio of the Aid flow from UN agencies (US$) of Middle income in 1979 to that in 1987?
Your response must be concise. 0.73. What is the ratio of the Aid flow from UN agencies (US$) in China in 1979 to that in 1987?
Give a very brief answer. 0.04. What is the ratio of the Aid flow from UN agencies (US$) of Morocco in 1979 to that in 1987?
Give a very brief answer. 0.38. What is the ratio of the Aid flow from UN agencies (US$) of Togo in 1979 to that in 1987?
Your answer should be compact. 0.3. What is the ratio of the Aid flow from UN agencies (US$) in Middle income in 1981 to that in 1982?
Offer a very short reply. 0.93. What is the ratio of the Aid flow from UN agencies (US$) of China in 1981 to that in 1982?
Keep it short and to the point. 0.45. What is the ratio of the Aid flow from UN agencies (US$) of Morocco in 1981 to that in 1982?
Provide a short and direct response. 1.1. What is the ratio of the Aid flow from UN agencies (US$) in Togo in 1981 to that in 1982?
Offer a very short reply. 1.58. What is the ratio of the Aid flow from UN agencies (US$) of Middle income in 1981 to that in 1983?
Give a very brief answer. 0.83. What is the ratio of the Aid flow from UN agencies (US$) in China in 1981 to that in 1983?
Offer a terse response. 0.28. What is the ratio of the Aid flow from UN agencies (US$) of Morocco in 1981 to that in 1983?
Provide a succinct answer. 1.18. What is the ratio of the Aid flow from UN agencies (US$) of Togo in 1981 to that in 1983?
Provide a short and direct response. 0.8. What is the ratio of the Aid flow from UN agencies (US$) in Middle income in 1981 to that in 1984?
Make the answer very short. 0.84. What is the ratio of the Aid flow from UN agencies (US$) of China in 1981 to that in 1984?
Ensure brevity in your answer.  0.09. What is the ratio of the Aid flow from UN agencies (US$) in Morocco in 1981 to that in 1984?
Offer a very short reply. 0.97. What is the ratio of the Aid flow from UN agencies (US$) of Togo in 1981 to that in 1984?
Ensure brevity in your answer.  0.91. What is the ratio of the Aid flow from UN agencies (US$) in Middle income in 1981 to that in 1985?
Your answer should be compact. 0.67. What is the ratio of the Aid flow from UN agencies (US$) in China in 1981 to that in 1985?
Make the answer very short. 0.1. What is the ratio of the Aid flow from UN agencies (US$) of Morocco in 1981 to that in 1985?
Your answer should be very brief. 0.87. What is the ratio of the Aid flow from UN agencies (US$) of Togo in 1981 to that in 1985?
Ensure brevity in your answer.  1.13. What is the ratio of the Aid flow from UN agencies (US$) of Middle income in 1981 to that in 1986?
Provide a succinct answer. 0.76. What is the ratio of the Aid flow from UN agencies (US$) of China in 1981 to that in 1986?
Make the answer very short. 0.08. What is the ratio of the Aid flow from UN agencies (US$) of Morocco in 1981 to that in 1986?
Provide a short and direct response. 0.71. What is the ratio of the Aid flow from UN agencies (US$) of Togo in 1981 to that in 1986?
Your answer should be compact. 1.24. What is the ratio of the Aid flow from UN agencies (US$) of Middle income in 1981 to that in 1987?
Your answer should be compact. 0.71. What is the ratio of the Aid flow from UN agencies (US$) of China in 1981 to that in 1987?
Make the answer very short. 0.08. What is the ratio of the Aid flow from UN agencies (US$) of Morocco in 1981 to that in 1987?
Ensure brevity in your answer.  1.37. What is the ratio of the Aid flow from UN agencies (US$) in Togo in 1981 to that in 1987?
Your answer should be compact. 1.23. What is the ratio of the Aid flow from UN agencies (US$) in Middle income in 1982 to that in 1983?
Offer a very short reply. 0.89. What is the ratio of the Aid flow from UN agencies (US$) of China in 1982 to that in 1983?
Give a very brief answer. 0.62. What is the ratio of the Aid flow from UN agencies (US$) in Morocco in 1982 to that in 1983?
Offer a very short reply. 1.08. What is the ratio of the Aid flow from UN agencies (US$) of Togo in 1982 to that in 1983?
Your answer should be very brief. 0.51. What is the ratio of the Aid flow from UN agencies (US$) in Middle income in 1982 to that in 1984?
Provide a succinct answer. 0.91. What is the ratio of the Aid flow from UN agencies (US$) in China in 1982 to that in 1984?
Your answer should be very brief. 0.19. What is the ratio of the Aid flow from UN agencies (US$) of Morocco in 1982 to that in 1984?
Your answer should be very brief. 0.89. What is the ratio of the Aid flow from UN agencies (US$) in Togo in 1982 to that in 1984?
Make the answer very short. 0.58. What is the ratio of the Aid flow from UN agencies (US$) in Middle income in 1982 to that in 1985?
Provide a succinct answer. 0.72. What is the ratio of the Aid flow from UN agencies (US$) in China in 1982 to that in 1985?
Ensure brevity in your answer.  0.23. What is the ratio of the Aid flow from UN agencies (US$) in Morocco in 1982 to that in 1985?
Your answer should be compact. 0.8. What is the ratio of the Aid flow from UN agencies (US$) of Togo in 1982 to that in 1985?
Give a very brief answer. 0.71. What is the ratio of the Aid flow from UN agencies (US$) in Middle income in 1982 to that in 1986?
Make the answer very short. 0.82. What is the ratio of the Aid flow from UN agencies (US$) in China in 1982 to that in 1986?
Give a very brief answer. 0.18. What is the ratio of the Aid flow from UN agencies (US$) in Morocco in 1982 to that in 1986?
Ensure brevity in your answer.  0.65. What is the ratio of the Aid flow from UN agencies (US$) of Togo in 1982 to that in 1986?
Offer a terse response. 0.78. What is the ratio of the Aid flow from UN agencies (US$) in Middle income in 1982 to that in 1987?
Provide a succinct answer. 0.77. What is the ratio of the Aid flow from UN agencies (US$) of China in 1982 to that in 1987?
Offer a very short reply. 0.18. What is the ratio of the Aid flow from UN agencies (US$) in Morocco in 1982 to that in 1987?
Provide a short and direct response. 1.25. What is the ratio of the Aid flow from UN agencies (US$) in Togo in 1982 to that in 1987?
Keep it short and to the point. 0.78. What is the ratio of the Aid flow from UN agencies (US$) of Middle income in 1983 to that in 1984?
Offer a very short reply. 1.01. What is the ratio of the Aid flow from UN agencies (US$) of China in 1983 to that in 1984?
Provide a short and direct response. 0.31. What is the ratio of the Aid flow from UN agencies (US$) in Morocco in 1983 to that in 1984?
Provide a short and direct response. 0.82. What is the ratio of the Aid flow from UN agencies (US$) of Togo in 1983 to that in 1984?
Keep it short and to the point. 1.14. What is the ratio of the Aid flow from UN agencies (US$) of Middle income in 1983 to that in 1985?
Your answer should be very brief. 0.81. What is the ratio of the Aid flow from UN agencies (US$) in China in 1983 to that in 1985?
Make the answer very short. 0.37. What is the ratio of the Aid flow from UN agencies (US$) in Morocco in 1983 to that in 1985?
Offer a terse response. 0.74. What is the ratio of the Aid flow from UN agencies (US$) in Togo in 1983 to that in 1985?
Give a very brief answer. 1.41. What is the ratio of the Aid flow from UN agencies (US$) of Middle income in 1983 to that in 1986?
Give a very brief answer. 0.91. What is the ratio of the Aid flow from UN agencies (US$) of China in 1983 to that in 1986?
Offer a terse response. 0.3. What is the ratio of the Aid flow from UN agencies (US$) of Morocco in 1983 to that in 1986?
Offer a terse response. 0.6. What is the ratio of the Aid flow from UN agencies (US$) of Togo in 1983 to that in 1986?
Provide a short and direct response. 1.55. What is the ratio of the Aid flow from UN agencies (US$) of Middle income in 1983 to that in 1987?
Your answer should be very brief. 0.86. What is the ratio of the Aid flow from UN agencies (US$) of China in 1983 to that in 1987?
Keep it short and to the point. 0.29. What is the ratio of the Aid flow from UN agencies (US$) of Morocco in 1983 to that in 1987?
Give a very brief answer. 1.16. What is the ratio of the Aid flow from UN agencies (US$) of Togo in 1983 to that in 1987?
Provide a short and direct response. 1.54. What is the ratio of the Aid flow from UN agencies (US$) in Middle income in 1984 to that in 1985?
Offer a very short reply. 0.8. What is the ratio of the Aid flow from UN agencies (US$) in China in 1984 to that in 1985?
Ensure brevity in your answer.  1.17. What is the ratio of the Aid flow from UN agencies (US$) of Morocco in 1984 to that in 1985?
Give a very brief answer. 0.9. What is the ratio of the Aid flow from UN agencies (US$) of Togo in 1984 to that in 1985?
Your response must be concise. 1.24. What is the ratio of the Aid flow from UN agencies (US$) of Middle income in 1984 to that in 1986?
Your answer should be compact. 0.9. What is the ratio of the Aid flow from UN agencies (US$) in China in 1984 to that in 1986?
Your answer should be very brief. 0.94. What is the ratio of the Aid flow from UN agencies (US$) of Morocco in 1984 to that in 1986?
Give a very brief answer. 0.73. What is the ratio of the Aid flow from UN agencies (US$) in Togo in 1984 to that in 1986?
Your answer should be compact. 1.36. What is the ratio of the Aid flow from UN agencies (US$) in Middle income in 1984 to that in 1987?
Your answer should be compact. 0.84. What is the ratio of the Aid flow from UN agencies (US$) in China in 1984 to that in 1987?
Your response must be concise. 0.92. What is the ratio of the Aid flow from UN agencies (US$) of Morocco in 1984 to that in 1987?
Keep it short and to the point. 1.41. What is the ratio of the Aid flow from UN agencies (US$) of Togo in 1984 to that in 1987?
Offer a terse response. 1.35. What is the ratio of the Aid flow from UN agencies (US$) in Middle income in 1985 to that in 1986?
Ensure brevity in your answer.  1.13. What is the ratio of the Aid flow from UN agencies (US$) of China in 1985 to that in 1986?
Keep it short and to the point. 0.8. What is the ratio of the Aid flow from UN agencies (US$) in Morocco in 1985 to that in 1986?
Your response must be concise. 0.82. What is the ratio of the Aid flow from UN agencies (US$) in Togo in 1985 to that in 1986?
Your response must be concise. 1.1. What is the ratio of the Aid flow from UN agencies (US$) in Middle income in 1985 to that in 1987?
Your answer should be very brief. 1.06. What is the ratio of the Aid flow from UN agencies (US$) in China in 1985 to that in 1987?
Make the answer very short. 0.79. What is the ratio of the Aid flow from UN agencies (US$) of Morocco in 1985 to that in 1987?
Your answer should be compact. 1.57. What is the ratio of the Aid flow from UN agencies (US$) in Togo in 1985 to that in 1987?
Make the answer very short. 1.09. What is the ratio of the Aid flow from UN agencies (US$) in Middle income in 1986 to that in 1987?
Your response must be concise. 0.94. What is the ratio of the Aid flow from UN agencies (US$) of China in 1986 to that in 1987?
Offer a terse response. 0.98. What is the ratio of the Aid flow from UN agencies (US$) of Morocco in 1986 to that in 1987?
Give a very brief answer. 1.92. What is the ratio of the Aid flow from UN agencies (US$) in Togo in 1986 to that in 1987?
Keep it short and to the point. 0.99. What is the difference between the highest and the second highest Aid flow from UN agencies (US$) in Middle income?
Your answer should be compact. 2.87e+07. What is the difference between the highest and the second highest Aid flow from UN agencies (US$) in China?
Provide a short and direct response. 1.96e+06. What is the difference between the highest and the second highest Aid flow from UN agencies (US$) of Morocco?
Your answer should be very brief. 4.05e+06. What is the difference between the highest and the lowest Aid flow from UN agencies (US$) of Middle income?
Provide a short and direct response. 1.68e+08. What is the difference between the highest and the lowest Aid flow from UN agencies (US$) in China?
Provide a short and direct response. 8.30e+07. What is the difference between the highest and the lowest Aid flow from UN agencies (US$) in Morocco?
Ensure brevity in your answer.  1.76e+07. What is the difference between the highest and the lowest Aid flow from UN agencies (US$) in Togo?
Provide a succinct answer. 1.98e+06. 